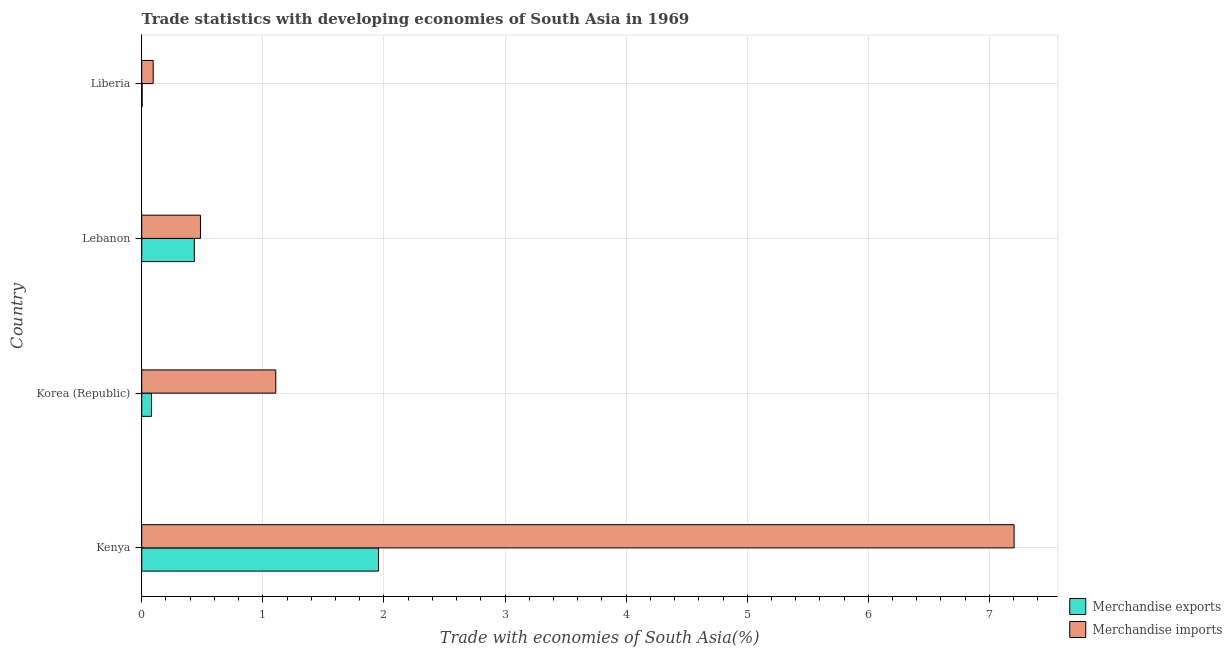How many groups of bars are there?
Your answer should be compact. 4. Are the number of bars per tick equal to the number of legend labels?
Give a very brief answer. Yes. Are the number of bars on each tick of the Y-axis equal?
Ensure brevity in your answer.  Yes. How many bars are there on the 3rd tick from the bottom?
Your answer should be compact. 2. What is the label of the 4th group of bars from the top?
Keep it short and to the point. Kenya. In how many cases, is the number of bars for a given country not equal to the number of legend labels?
Offer a very short reply. 0. What is the merchandise imports in Lebanon?
Provide a succinct answer. 0.48. Across all countries, what is the maximum merchandise imports?
Your response must be concise. 7.2. Across all countries, what is the minimum merchandise exports?
Give a very brief answer. 0. In which country was the merchandise exports maximum?
Offer a terse response. Kenya. In which country was the merchandise imports minimum?
Your response must be concise. Liberia. What is the total merchandise imports in the graph?
Give a very brief answer. 8.89. What is the difference between the merchandise exports in Kenya and that in Liberia?
Provide a short and direct response. 1.95. What is the difference between the merchandise imports in Korea (Republic) and the merchandise exports in Lebanon?
Give a very brief answer. 0.67. What is the average merchandise exports per country?
Offer a very short reply. 0.62. In how many countries, is the merchandise imports greater than 0.6000000000000001 %?
Offer a very short reply. 2. What is the ratio of the merchandise imports in Korea (Republic) to that in Liberia?
Offer a very short reply. 11.71. What is the difference between the highest and the second highest merchandise exports?
Your answer should be compact. 1.52. What is the difference between the highest and the lowest merchandise exports?
Make the answer very short. 1.95. What does the 1st bar from the top in Lebanon represents?
Your response must be concise. Merchandise imports. What does the 1st bar from the bottom in Korea (Republic) represents?
Provide a succinct answer. Merchandise exports. How many bars are there?
Your answer should be compact. 8. Are the values on the major ticks of X-axis written in scientific E-notation?
Keep it short and to the point. No. Does the graph contain any zero values?
Provide a short and direct response. No. How many legend labels are there?
Your answer should be very brief. 2. How are the legend labels stacked?
Offer a terse response. Vertical. What is the title of the graph?
Offer a very short reply. Trade statistics with developing economies of South Asia in 1969. What is the label or title of the X-axis?
Provide a succinct answer. Trade with economies of South Asia(%). What is the Trade with economies of South Asia(%) of Merchandise exports in Kenya?
Keep it short and to the point. 1.96. What is the Trade with economies of South Asia(%) of Merchandise imports in Kenya?
Provide a succinct answer. 7.2. What is the Trade with economies of South Asia(%) in Merchandise exports in Korea (Republic)?
Ensure brevity in your answer.  0.08. What is the Trade with economies of South Asia(%) in Merchandise imports in Korea (Republic)?
Keep it short and to the point. 1.11. What is the Trade with economies of South Asia(%) in Merchandise exports in Lebanon?
Provide a short and direct response. 0.43. What is the Trade with economies of South Asia(%) of Merchandise imports in Lebanon?
Give a very brief answer. 0.48. What is the Trade with economies of South Asia(%) of Merchandise exports in Liberia?
Your answer should be compact. 0. What is the Trade with economies of South Asia(%) in Merchandise imports in Liberia?
Provide a succinct answer. 0.09. Across all countries, what is the maximum Trade with economies of South Asia(%) of Merchandise exports?
Offer a very short reply. 1.96. Across all countries, what is the maximum Trade with economies of South Asia(%) of Merchandise imports?
Offer a very short reply. 7.2. Across all countries, what is the minimum Trade with economies of South Asia(%) in Merchandise exports?
Your answer should be compact. 0. Across all countries, what is the minimum Trade with economies of South Asia(%) of Merchandise imports?
Your response must be concise. 0.09. What is the total Trade with economies of South Asia(%) of Merchandise exports in the graph?
Provide a succinct answer. 2.47. What is the total Trade with economies of South Asia(%) in Merchandise imports in the graph?
Your response must be concise. 8.89. What is the difference between the Trade with economies of South Asia(%) of Merchandise exports in Kenya and that in Korea (Republic)?
Provide a succinct answer. 1.88. What is the difference between the Trade with economies of South Asia(%) in Merchandise imports in Kenya and that in Korea (Republic)?
Offer a terse response. 6.1. What is the difference between the Trade with economies of South Asia(%) in Merchandise exports in Kenya and that in Lebanon?
Your answer should be very brief. 1.52. What is the difference between the Trade with economies of South Asia(%) in Merchandise imports in Kenya and that in Lebanon?
Offer a terse response. 6.72. What is the difference between the Trade with economies of South Asia(%) in Merchandise exports in Kenya and that in Liberia?
Keep it short and to the point. 1.95. What is the difference between the Trade with economies of South Asia(%) in Merchandise imports in Kenya and that in Liberia?
Your response must be concise. 7.11. What is the difference between the Trade with economies of South Asia(%) of Merchandise exports in Korea (Republic) and that in Lebanon?
Provide a succinct answer. -0.35. What is the difference between the Trade with economies of South Asia(%) of Merchandise imports in Korea (Republic) and that in Lebanon?
Ensure brevity in your answer.  0.62. What is the difference between the Trade with economies of South Asia(%) of Merchandise exports in Korea (Republic) and that in Liberia?
Offer a very short reply. 0.08. What is the difference between the Trade with economies of South Asia(%) in Merchandise imports in Korea (Republic) and that in Liberia?
Make the answer very short. 1.01. What is the difference between the Trade with economies of South Asia(%) in Merchandise exports in Lebanon and that in Liberia?
Your response must be concise. 0.43. What is the difference between the Trade with economies of South Asia(%) of Merchandise imports in Lebanon and that in Liberia?
Offer a very short reply. 0.39. What is the difference between the Trade with economies of South Asia(%) of Merchandise exports in Kenya and the Trade with economies of South Asia(%) of Merchandise imports in Korea (Republic)?
Make the answer very short. 0.85. What is the difference between the Trade with economies of South Asia(%) in Merchandise exports in Kenya and the Trade with economies of South Asia(%) in Merchandise imports in Lebanon?
Provide a short and direct response. 1.47. What is the difference between the Trade with economies of South Asia(%) in Merchandise exports in Kenya and the Trade with economies of South Asia(%) in Merchandise imports in Liberia?
Offer a very short reply. 1.86. What is the difference between the Trade with economies of South Asia(%) of Merchandise exports in Korea (Republic) and the Trade with economies of South Asia(%) of Merchandise imports in Lebanon?
Your answer should be compact. -0.4. What is the difference between the Trade with economies of South Asia(%) in Merchandise exports in Korea (Republic) and the Trade with economies of South Asia(%) in Merchandise imports in Liberia?
Provide a short and direct response. -0.01. What is the difference between the Trade with economies of South Asia(%) in Merchandise exports in Lebanon and the Trade with economies of South Asia(%) in Merchandise imports in Liberia?
Keep it short and to the point. 0.34. What is the average Trade with economies of South Asia(%) in Merchandise exports per country?
Your answer should be very brief. 0.62. What is the average Trade with economies of South Asia(%) of Merchandise imports per country?
Your response must be concise. 2.22. What is the difference between the Trade with economies of South Asia(%) of Merchandise exports and Trade with economies of South Asia(%) of Merchandise imports in Kenya?
Provide a succinct answer. -5.25. What is the difference between the Trade with economies of South Asia(%) in Merchandise exports and Trade with economies of South Asia(%) in Merchandise imports in Korea (Republic)?
Offer a terse response. -1.03. What is the difference between the Trade with economies of South Asia(%) in Merchandise exports and Trade with economies of South Asia(%) in Merchandise imports in Lebanon?
Keep it short and to the point. -0.05. What is the difference between the Trade with economies of South Asia(%) in Merchandise exports and Trade with economies of South Asia(%) in Merchandise imports in Liberia?
Ensure brevity in your answer.  -0.09. What is the ratio of the Trade with economies of South Asia(%) in Merchandise exports in Kenya to that in Korea (Republic)?
Provide a short and direct response. 24.35. What is the ratio of the Trade with economies of South Asia(%) in Merchandise imports in Kenya to that in Korea (Republic)?
Provide a short and direct response. 6.51. What is the ratio of the Trade with economies of South Asia(%) in Merchandise exports in Kenya to that in Lebanon?
Give a very brief answer. 4.5. What is the ratio of the Trade with economies of South Asia(%) in Merchandise imports in Kenya to that in Lebanon?
Your answer should be compact. 14.85. What is the ratio of the Trade with economies of South Asia(%) in Merchandise exports in Kenya to that in Liberia?
Give a very brief answer. 569.31. What is the ratio of the Trade with economies of South Asia(%) in Merchandise imports in Kenya to that in Liberia?
Make the answer very short. 76.19. What is the ratio of the Trade with economies of South Asia(%) in Merchandise exports in Korea (Republic) to that in Lebanon?
Ensure brevity in your answer.  0.18. What is the ratio of the Trade with economies of South Asia(%) in Merchandise imports in Korea (Republic) to that in Lebanon?
Your answer should be compact. 2.28. What is the ratio of the Trade with economies of South Asia(%) of Merchandise exports in Korea (Republic) to that in Liberia?
Provide a succinct answer. 23.38. What is the ratio of the Trade with economies of South Asia(%) of Merchandise imports in Korea (Republic) to that in Liberia?
Keep it short and to the point. 11.71. What is the ratio of the Trade with economies of South Asia(%) in Merchandise exports in Lebanon to that in Liberia?
Offer a terse response. 126.49. What is the ratio of the Trade with economies of South Asia(%) in Merchandise imports in Lebanon to that in Liberia?
Provide a succinct answer. 5.13. What is the difference between the highest and the second highest Trade with economies of South Asia(%) in Merchandise exports?
Your answer should be very brief. 1.52. What is the difference between the highest and the second highest Trade with economies of South Asia(%) in Merchandise imports?
Your answer should be compact. 6.1. What is the difference between the highest and the lowest Trade with economies of South Asia(%) in Merchandise exports?
Offer a terse response. 1.95. What is the difference between the highest and the lowest Trade with economies of South Asia(%) in Merchandise imports?
Your answer should be compact. 7.11. 